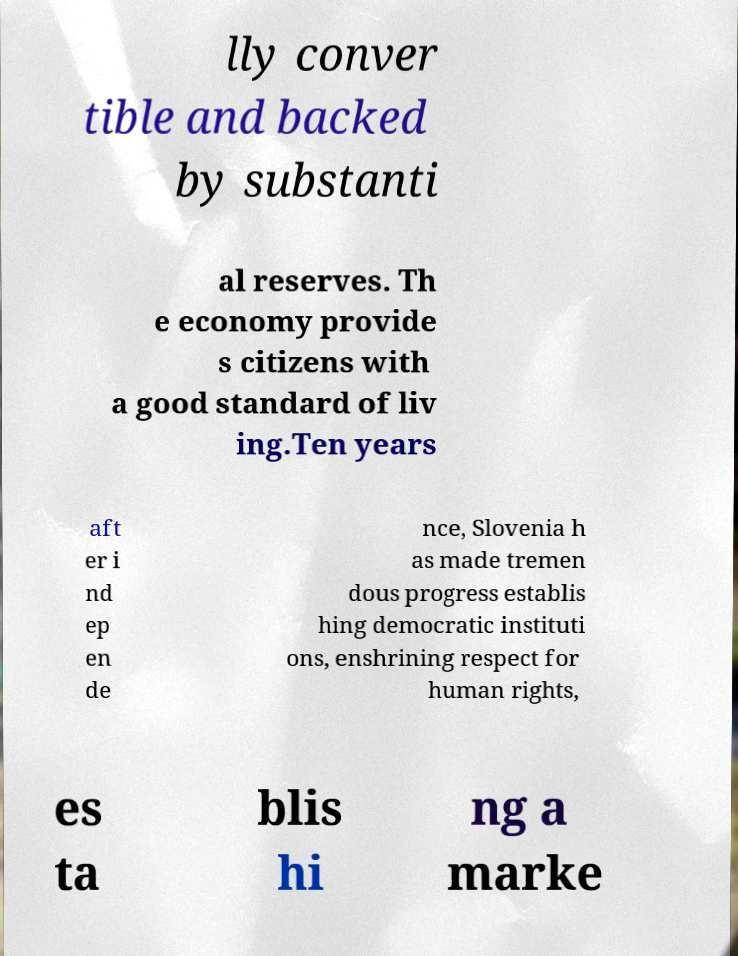Could you assist in decoding the text presented in this image and type it out clearly? lly conver tible and backed by substanti al reserves. Th e economy provide s citizens with a good standard of liv ing.Ten years aft er i nd ep en de nce, Slovenia h as made tremen dous progress establis hing democratic instituti ons, enshrining respect for human rights, es ta blis hi ng a marke 